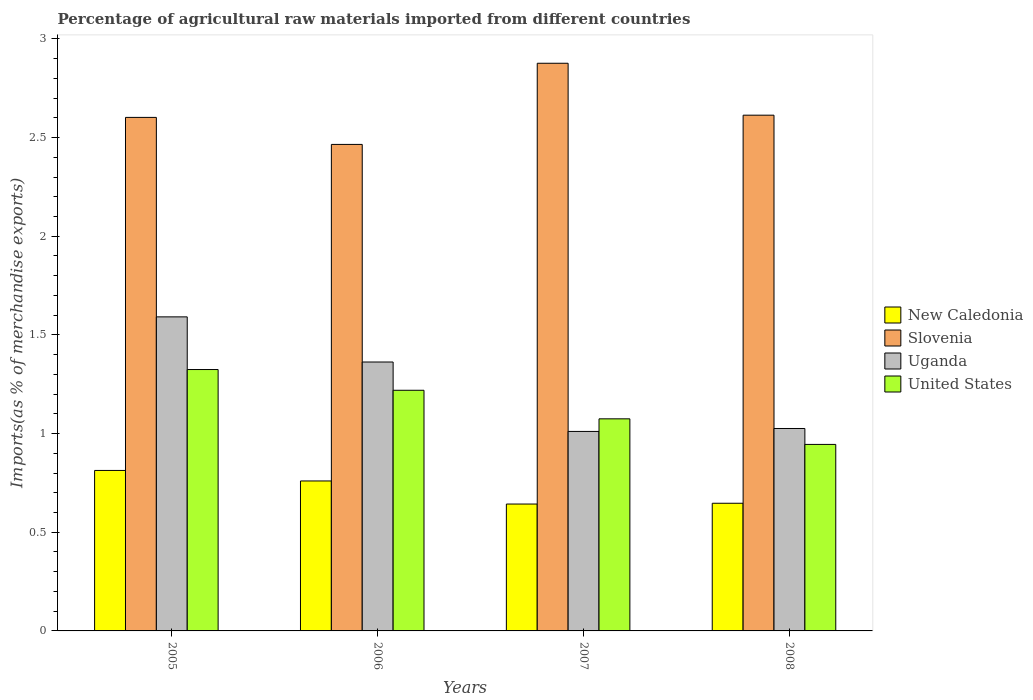How many groups of bars are there?
Your answer should be compact. 4. Are the number of bars per tick equal to the number of legend labels?
Offer a very short reply. Yes. How many bars are there on the 4th tick from the right?
Offer a very short reply. 4. What is the label of the 1st group of bars from the left?
Your response must be concise. 2005. What is the percentage of imports to different countries in New Caledonia in 2006?
Offer a terse response. 0.76. Across all years, what is the maximum percentage of imports to different countries in New Caledonia?
Provide a short and direct response. 0.81. Across all years, what is the minimum percentage of imports to different countries in Uganda?
Offer a terse response. 1.01. In which year was the percentage of imports to different countries in New Caledonia maximum?
Offer a very short reply. 2005. What is the total percentage of imports to different countries in United States in the graph?
Give a very brief answer. 4.56. What is the difference between the percentage of imports to different countries in United States in 2005 and that in 2007?
Your answer should be compact. 0.25. What is the difference between the percentage of imports to different countries in New Caledonia in 2008 and the percentage of imports to different countries in Slovenia in 2006?
Offer a very short reply. -1.82. What is the average percentage of imports to different countries in Uganda per year?
Offer a terse response. 1.25. In the year 2007, what is the difference between the percentage of imports to different countries in Uganda and percentage of imports to different countries in United States?
Your answer should be very brief. -0.06. What is the ratio of the percentage of imports to different countries in Uganda in 2006 to that in 2008?
Offer a terse response. 1.33. Is the difference between the percentage of imports to different countries in Uganda in 2005 and 2006 greater than the difference between the percentage of imports to different countries in United States in 2005 and 2006?
Give a very brief answer. Yes. What is the difference between the highest and the second highest percentage of imports to different countries in Uganda?
Make the answer very short. 0.23. What is the difference between the highest and the lowest percentage of imports to different countries in New Caledonia?
Offer a very short reply. 0.17. In how many years, is the percentage of imports to different countries in United States greater than the average percentage of imports to different countries in United States taken over all years?
Offer a very short reply. 2. Is the sum of the percentage of imports to different countries in Slovenia in 2005 and 2006 greater than the maximum percentage of imports to different countries in New Caledonia across all years?
Ensure brevity in your answer.  Yes. What does the 3rd bar from the left in 2008 represents?
Provide a succinct answer. Uganda. Is it the case that in every year, the sum of the percentage of imports to different countries in New Caledonia and percentage of imports to different countries in Slovenia is greater than the percentage of imports to different countries in Uganda?
Provide a succinct answer. Yes. How many bars are there?
Your answer should be very brief. 16. How many years are there in the graph?
Provide a short and direct response. 4. What is the difference between two consecutive major ticks on the Y-axis?
Give a very brief answer. 0.5. Are the values on the major ticks of Y-axis written in scientific E-notation?
Your answer should be compact. No. How many legend labels are there?
Your answer should be very brief. 4. What is the title of the graph?
Your response must be concise. Percentage of agricultural raw materials imported from different countries. Does "New Caledonia" appear as one of the legend labels in the graph?
Your answer should be very brief. Yes. What is the label or title of the Y-axis?
Your answer should be very brief. Imports(as % of merchandise exports). What is the Imports(as % of merchandise exports) in New Caledonia in 2005?
Your response must be concise. 0.81. What is the Imports(as % of merchandise exports) of Slovenia in 2005?
Keep it short and to the point. 2.6. What is the Imports(as % of merchandise exports) of Uganda in 2005?
Provide a short and direct response. 1.59. What is the Imports(as % of merchandise exports) of United States in 2005?
Provide a succinct answer. 1.32. What is the Imports(as % of merchandise exports) of New Caledonia in 2006?
Your response must be concise. 0.76. What is the Imports(as % of merchandise exports) of Slovenia in 2006?
Provide a short and direct response. 2.47. What is the Imports(as % of merchandise exports) of Uganda in 2006?
Your response must be concise. 1.36. What is the Imports(as % of merchandise exports) in United States in 2006?
Your response must be concise. 1.22. What is the Imports(as % of merchandise exports) in New Caledonia in 2007?
Provide a short and direct response. 0.64. What is the Imports(as % of merchandise exports) in Slovenia in 2007?
Keep it short and to the point. 2.88. What is the Imports(as % of merchandise exports) in Uganda in 2007?
Your answer should be compact. 1.01. What is the Imports(as % of merchandise exports) in United States in 2007?
Ensure brevity in your answer.  1.07. What is the Imports(as % of merchandise exports) of New Caledonia in 2008?
Offer a terse response. 0.65. What is the Imports(as % of merchandise exports) of Slovenia in 2008?
Provide a short and direct response. 2.61. What is the Imports(as % of merchandise exports) in Uganda in 2008?
Keep it short and to the point. 1.03. What is the Imports(as % of merchandise exports) of United States in 2008?
Keep it short and to the point. 0.95. Across all years, what is the maximum Imports(as % of merchandise exports) in New Caledonia?
Your answer should be very brief. 0.81. Across all years, what is the maximum Imports(as % of merchandise exports) in Slovenia?
Your answer should be compact. 2.88. Across all years, what is the maximum Imports(as % of merchandise exports) in Uganda?
Keep it short and to the point. 1.59. Across all years, what is the maximum Imports(as % of merchandise exports) of United States?
Offer a very short reply. 1.32. Across all years, what is the minimum Imports(as % of merchandise exports) in New Caledonia?
Make the answer very short. 0.64. Across all years, what is the minimum Imports(as % of merchandise exports) of Slovenia?
Give a very brief answer. 2.47. Across all years, what is the minimum Imports(as % of merchandise exports) of Uganda?
Provide a short and direct response. 1.01. Across all years, what is the minimum Imports(as % of merchandise exports) of United States?
Your answer should be very brief. 0.95. What is the total Imports(as % of merchandise exports) of New Caledonia in the graph?
Offer a terse response. 2.86. What is the total Imports(as % of merchandise exports) in Slovenia in the graph?
Offer a terse response. 10.56. What is the total Imports(as % of merchandise exports) of Uganda in the graph?
Offer a terse response. 4.99. What is the total Imports(as % of merchandise exports) of United States in the graph?
Make the answer very short. 4.56. What is the difference between the Imports(as % of merchandise exports) in New Caledonia in 2005 and that in 2006?
Offer a terse response. 0.05. What is the difference between the Imports(as % of merchandise exports) in Slovenia in 2005 and that in 2006?
Your answer should be very brief. 0.14. What is the difference between the Imports(as % of merchandise exports) of Uganda in 2005 and that in 2006?
Your answer should be compact. 0.23. What is the difference between the Imports(as % of merchandise exports) in United States in 2005 and that in 2006?
Your response must be concise. 0.11. What is the difference between the Imports(as % of merchandise exports) of New Caledonia in 2005 and that in 2007?
Provide a succinct answer. 0.17. What is the difference between the Imports(as % of merchandise exports) in Slovenia in 2005 and that in 2007?
Your answer should be compact. -0.27. What is the difference between the Imports(as % of merchandise exports) in Uganda in 2005 and that in 2007?
Your answer should be very brief. 0.58. What is the difference between the Imports(as % of merchandise exports) of United States in 2005 and that in 2007?
Offer a terse response. 0.25. What is the difference between the Imports(as % of merchandise exports) of New Caledonia in 2005 and that in 2008?
Ensure brevity in your answer.  0.17. What is the difference between the Imports(as % of merchandise exports) of Slovenia in 2005 and that in 2008?
Your answer should be compact. -0.01. What is the difference between the Imports(as % of merchandise exports) of Uganda in 2005 and that in 2008?
Provide a succinct answer. 0.57. What is the difference between the Imports(as % of merchandise exports) of United States in 2005 and that in 2008?
Offer a very short reply. 0.38. What is the difference between the Imports(as % of merchandise exports) of New Caledonia in 2006 and that in 2007?
Your answer should be very brief. 0.12. What is the difference between the Imports(as % of merchandise exports) in Slovenia in 2006 and that in 2007?
Offer a very short reply. -0.41. What is the difference between the Imports(as % of merchandise exports) in Uganda in 2006 and that in 2007?
Offer a very short reply. 0.35. What is the difference between the Imports(as % of merchandise exports) of United States in 2006 and that in 2007?
Give a very brief answer. 0.14. What is the difference between the Imports(as % of merchandise exports) in New Caledonia in 2006 and that in 2008?
Ensure brevity in your answer.  0.11. What is the difference between the Imports(as % of merchandise exports) of Slovenia in 2006 and that in 2008?
Make the answer very short. -0.15. What is the difference between the Imports(as % of merchandise exports) in Uganda in 2006 and that in 2008?
Ensure brevity in your answer.  0.34. What is the difference between the Imports(as % of merchandise exports) of United States in 2006 and that in 2008?
Offer a terse response. 0.27. What is the difference between the Imports(as % of merchandise exports) of New Caledonia in 2007 and that in 2008?
Offer a very short reply. -0. What is the difference between the Imports(as % of merchandise exports) of Slovenia in 2007 and that in 2008?
Make the answer very short. 0.26. What is the difference between the Imports(as % of merchandise exports) in Uganda in 2007 and that in 2008?
Your response must be concise. -0.01. What is the difference between the Imports(as % of merchandise exports) of United States in 2007 and that in 2008?
Provide a succinct answer. 0.13. What is the difference between the Imports(as % of merchandise exports) in New Caledonia in 2005 and the Imports(as % of merchandise exports) in Slovenia in 2006?
Offer a very short reply. -1.65. What is the difference between the Imports(as % of merchandise exports) of New Caledonia in 2005 and the Imports(as % of merchandise exports) of Uganda in 2006?
Ensure brevity in your answer.  -0.55. What is the difference between the Imports(as % of merchandise exports) of New Caledonia in 2005 and the Imports(as % of merchandise exports) of United States in 2006?
Give a very brief answer. -0.41. What is the difference between the Imports(as % of merchandise exports) in Slovenia in 2005 and the Imports(as % of merchandise exports) in Uganda in 2006?
Provide a short and direct response. 1.24. What is the difference between the Imports(as % of merchandise exports) in Slovenia in 2005 and the Imports(as % of merchandise exports) in United States in 2006?
Your answer should be compact. 1.38. What is the difference between the Imports(as % of merchandise exports) of Uganda in 2005 and the Imports(as % of merchandise exports) of United States in 2006?
Make the answer very short. 0.37. What is the difference between the Imports(as % of merchandise exports) in New Caledonia in 2005 and the Imports(as % of merchandise exports) in Slovenia in 2007?
Give a very brief answer. -2.06. What is the difference between the Imports(as % of merchandise exports) of New Caledonia in 2005 and the Imports(as % of merchandise exports) of Uganda in 2007?
Make the answer very short. -0.2. What is the difference between the Imports(as % of merchandise exports) in New Caledonia in 2005 and the Imports(as % of merchandise exports) in United States in 2007?
Offer a very short reply. -0.26. What is the difference between the Imports(as % of merchandise exports) of Slovenia in 2005 and the Imports(as % of merchandise exports) of Uganda in 2007?
Your answer should be very brief. 1.59. What is the difference between the Imports(as % of merchandise exports) in Slovenia in 2005 and the Imports(as % of merchandise exports) in United States in 2007?
Give a very brief answer. 1.53. What is the difference between the Imports(as % of merchandise exports) of Uganda in 2005 and the Imports(as % of merchandise exports) of United States in 2007?
Make the answer very short. 0.52. What is the difference between the Imports(as % of merchandise exports) in New Caledonia in 2005 and the Imports(as % of merchandise exports) in Slovenia in 2008?
Offer a very short reply. -1.8. What is the difference between the Imports(as % of merchandise exports) of New Caledonia in 2005 and the Imports(as % of merchandise exports) of Uganda in 2008?
Ensure brevity in your answer.  -0.21. What is the difference between the Imports(as % of merchandise exports) in New Caledonia in 2005 and the Imports(as % of merchandise exports) in United States in 2008?
Make the answer very short. -0.13. What is the difference between the Imports(as % of merchandise exports) in Slovenia in 2005 and the Imports(as % of merchandise exports) in Uganda in 2008?
Give a very brief answer. 1.58. What is the difference between the Imports(as % of merchandise exports) in Slovenia in 2005 and the Imports(as % of merchandise exports) in United States in 2008?
Ensure brevity in your answer.  1.66. What is the difference between the Imports(as % of merchandise exports) in Uganda in 2005 and the Imports(as % of merchandise exports) in United States in 2008?
Your answer should be compact. 0.65. What is the difference between the Imports(as % of merchandise exports) of New Caledonia in 2006 and the Imports(as % of merchandise exports) of Slovenia in 2007?
Offer a very short reply. -2.12. What is the difference between the Imports(as % of merchandise exports) in New Caledonia in 2006 and the Imports(as % of merchandise exports) in Uganda in 2007?
Make the answer very short. -0.25. What is the difference between the Imports(as % of merchandise exports) in New Caledonia in 2006 and the Imports(as % of merchandise exports) in United States in 2007?
Your answer should be compact. -0.31. What is the difference between the Imports(as % of merchandise exports) of Slovenia in 2006 and the Imports(as % of merchandise exports) of Uganda in 2007?
Keep it short and to the point. 1.45. What is the difference between the Imports(as % of merchandise exports) in Slovenia in 2006 and the Imports(as % of merchandise exports) in United States in 2007?
Your response must be concise. 1.39. What is the difference between the Imports(as % of merchandise exports) of Uganda in 2006 and the Imports(as % of merchandise exports) of United States in 2007?
Offer a very short reply. 0.29. What is the difference between the Imports(as % of merchandise exports) in New Caledonia in 2006 and the Imports(as % of merchandise exports) in Slovenia in 2008?
Offer a very short reply. -1.85. What is the difference between the Imports(as % of merchandise exports) of New Caledonia in 2006 and the Imports(as % of merchandise exports) of Uganda in 2008?
Your answer should be compact. -0.27. What is the difference between the Imports(as % of merchandise exports) of New Caledonia in 2006 and the Imports(as % of merchandise exports) of United States in 2008?
Offer a very short reply. -0.19. What is the difference between the Imports(as % of merchandise exports) in Slovenia in 2006 and the Imports(as % of merchandise exports) in Uganda in 2008?
Provide a succinct answer. 1.44. What is the difference between the Imports(as % of merchandise exports) in Slovenia in 2006 and the Imports(as % of merchandise exports) in United States in 2008?
Your answer should be very brief. 1.52. What is the difference between the Imports(as % of merchandise exports) of Uganda in 2006 and the Imports(as % of merchandise exports) of United States in 2008?
Offer a terse response. 0.42. What is the difference between the Imports(as % of merchandise exports) in New Caledonia in 2007 and the Imports(as % of merchandise exports) in Slovenia in 2008?
Make the answer very short. -1.97. What is the difference between the Imports(as % of merchandise exports) in New Caledonia in 2007 and the Imports(as % of merchandise exports) in Uganda in 2008?
Give a very brief answer. -0.38. What is the difference between the Imports(as % of merchandise exports) of New Caledonia in 2007 and the Imports(as % of merchandise exports) of United States in 2008?
Make the answer very short. -0.3. What is the difference between the Imports(as % of merchandise exports) of Slovenia in 2007 and the Imports(as % of merchandise exports) of Uganda in 2008?
Offer a terse response. 1.85. What is the difference between the Imports(as % of merchandise exports) in Slovenia in 2007 and the Imports(as % of merchandise exports) in United States in 2008?
Give a very brief answer. 1.93. What is the difference between the Imports(as % of merchandise exports) in Uganda in 2007 and the Imports(as % of merchandise exports) in United States in 2008?
Ensure brevity in your answer.  0.07. What is the average Imports(as % of merchandise exports) of New Caledonia per year?
Offer a terse response. 0.72. What is the average Imports(as % of merchandise exports) of Slovenia per year?
Keep it short and to the point. 2.64. What is the average Imports(as % of merchandise exports) in Uganda per year?
Offer a terse response. 1.25. What is the average Imports(as % of merchandise exports) in United States per year?
Offer a terse response. 1.14. In the year 2005, what is the difference between the Imports(as % of merchandise exports) of New Caledonia and Imports(as % of merchandise exports) of Slovenia?
Offer a very short reply. -1.79. In the year 2005, what is the difference between the Imports(as % of merchandise exports) in New Caledonia and Imports(as % of merchandise exports) in Uganda?
Keep it short and to the point. -0.78. In the year 2005, what is the difference between the Imports(as % of merchandise exports) of New Caledonia and Imports(as % of merchandise exports) of United States?
Offer a terse response. -0.51. In the year 2005, what is the difference between the Imports(as % of merchandise exports) of Slovenia and Imports(as % of merchandise exports) of Uganda?
Ensure brevity in your answer.  1.01. In the year 2005, what is the difference between the Imports(as % of merchandise exports) of Slovenia and Imports(as % of merchandise exports) of United States?
Offer a terse response. 1.28. In the year 2005, what is the difference between the Imports(as % of merchandise exports) in Uganda and Imports(as % of merchandise exports) in United States?
Offer a very short reply. 0.27. In the year 2006, what is the difference between the Imports(as % of merchandise exports) in New Caledonia and Imports(as % of merchandise exports) in Slovenia?
Offer a terse response. -1.71. In the year 2006, what is the difference between the Imports(as % of merchandise exports) of New Caledonia and Imports(as % of merchandise exports) of Uganda?
Your answer should be very brief. -0.6. In the year 2006, what is the difference between the Imports(as % of merchandise exports) of New Caledonia and Imports(as % of merchandise exports) of United States?
Give a very brief answer. -0.46. In the year 2006, what is the difference between the Imports(as % of merchandise exports) of Slovenia and Imports(as % of merchandise exports) of Uganda?
Keep it short and to the point. 1.1. In the year 2006, what is the difference between the Imports(as % of merchandise exports) in Slovenia and Imports(as % of merchandise exports) in United States?
Make the answer very short. 1.25. In the year 2006, what is the difference between the Imports(as % of merchandise exports) of Uganda and Imports(as % of merchandise exports) of United States?
Ensure brevity in your answer.  0.14. In the year 2007, what is the difference between the Imports(as % of merchandise exports) of New Caledonia and Imports(as % of merchandise exports) of Slovenia?
Keep it short and to the point. -2.23. In the year 2007, what is the difference between the Imports(as % of merchandise exports) of New Caledonia and Imports(as % of merchandise exports) of Uganda?
Provide a short and direct response. -0.37. In the year 2007, what is the difference between the Imports(as % of merchandise exports) in New Caledonia and Imports(as % of merchandise exports) in United States?
Make the answer very short. -0.43. In the year 2007, what is the difference between the Imports(as % of merchandise exports) of Slovenia and Imports(as % of merchandise exports) of Uganda?
Keep it short and to the point. 1.87. In the year 2007, what is the difference between the Imports(as % of merchandise exports) in Slovenia and Imports(as % of merchandise exports) in United States?
Make the answer very short. 1.8. In the year 2007, what is the difference between the Imports(as % of merchandise exports) in Uganda and Imports(as % of merchandise exports) in United States?
Provide a short and direct response. -0.06. In the year 2008, what is the difference between the Imports(as % of merchandise exports) of New Caledonia and Imports(as % of merchandise exports) of Slovenia?
Your answer should be very brief. -1.97. In the year 2008, what is the difference between the Imports(as % of merchandise exports) in New Caledonia and Imports(as % of merchandise exports) in Uganda?
Ensure brevity in your answer.  -0.38. In the year 2008, what is the difference between the Imports(as % of merchandise exports) of New Caledonia and Imports(as % of merchandise exports) of United States?
Offer a terse response. -0.3. In the year 2008, what is the difference between the Imports(as % of merchandise exports) of Slovenia and Imports(as % of merchandise exports) of Uganda?
Make the answer very short. 1.59. In the year 2008, what is the difference between the Imports(as % of merchandise exports) of Slovenia and Imports(as % of merchandise exports) of United States?
Give a very brief answer. 1.67. In the year 2008, what is the difference between the Imports(as % of merchandise exports) in Uganda and Imports(as % of merchandise exports) in United States?
Make the answer very short. 0.08. What is the ratio of the Imports(as % of merchandise exports) in New Caledonia in 2005 to that in 2006?
Your response must be concise. 1.07. What is the ratio of the Imports(as % of merchandise exports) of Slovenia in 2005 to that in 2006?
Offer a terse response. 1.06. What is the ratio of the Imports(as % of merchandise exports) in Uganda in 2005 to that in 2006?
Your answer should be compact. 1.17. What is the ratio of the Imports(as % of merchandise exports) in United States in 2005 to that in 2006?
Your answer should be compact. 1.09. What is the ratio of the Imports(as % of merchandise exports) of New Caledonia in 2005 to that in 2007?
Keep it short and to the point. 1.26. What is the ratio of the Imports(as % of merchandise exports) in Slovenia in 2005 to that in 2007?
Ensure brevity in your answer.  0.9. What is the ratio of the Imports(as % of merchandise exports) of Uganda in 2005 to that in 2007?
Provide a succinct answer. 1.57. What is the ratio of the Imports(as % of merchandise exports) in United States in 2005 to that in 2007?
Provide a succinct answer. 1.23. What is the ratio of the Imports(as % of merchandise exports) in New Caledonia in 2005 to that in 2008?
Your answer should be compact. 1.26. What is the ratio of the Imports(as % of merchandise exports) in Uganda in 2005 to that in 2008?
Your response must be concise. 1.55. What is the ratio of the Imports(as % of merchandise exports) of United States in 2005 to that in 2008?
Your answer should be compact. 1.4. What is the ratio of the Imports(as % of merchandise exports) in New Caledonia in 2006 to that in 2007?
Your response must be concise. 1.18. What is the ratio of the Imports(as % of merchandise exports) of Slovenia in 2006 to that in 2007?
Offer a very short reply. 0.86. What is the ratio of the Imports(as % of merchandise exports) in Uganda in 2006 to that in 2007?
Provide a short and direct response. 1.35. What is the ratio of the Imports(as % of merchandise exports) of United States in 2006 to that in 2007?
Offer a terse response. 1.13. What is the ratio of the Imports(as % of merchandise exports) in New Caledonia in 2006 to that in 2008?
Provide a succinct answer. 1.17. What is the ratio of the Imports(as % of merchandise exports) of Slovenia in 2006 to that in 2008?
Make the answer very short. 0.94. What is the ratio of the Imports(as % of merchandise exports) of Uganda in 2006 to that in 2008?
Give a very brief answer. 1.33. What is the ratio of the Imports(as % of merchandise exports) of United States in 2006 to that in 2008?
Make the answer very short. 1.29. What is the ratio of the Imports(as % of merchandise exports) in Slovenia in 2007 to that in 2008?
Make the answer very short. 1.1. What is the ratio of the Imports(as % of merchandise exports) of Uganda in 2007 to that in 2008?
Your answer should be very brief. 0.99. What is the ratio of the Imports(as % of merchandise exports) in United States in 2007 to that in 2008?
Make the answer very short. 1.14. What is the difference between the highest and the second highest Imports(as % of merchandise exports) of New Caledonia?
Make the answer very short. 0.05. What is the difference between the highest and the second highest Imports(as % of merchandise exports) of Slovenia?
Offer a terse response. 0.26. What is the difference between the highest and the second highest Imports(as % of merchandise exports) in Uganda?
Make the answer very short. 0.23. What is the difference between the highest and the second highest Imports(as % of merchandise exports) in United States?
Your response must be concise. 0.11. What is the difference between the highest and the lowest Imports(as % of merchandise exports) in New Caledonia?
Provide a succinct answer. 0.17. What is the difference between the highest and the lowest Imports(as % of merchandise exports) in Slovenia?
Give a very brief answer. 0.41. What is the difference between the highest and the lowest Imports(as % of merchandise exports) of Uganda?
Offer a terse response. 0.58. What is the difference between the highest and the lowest Imports(as % of merchandise exports) of United States?
Offer a very short reply. 0.38. 